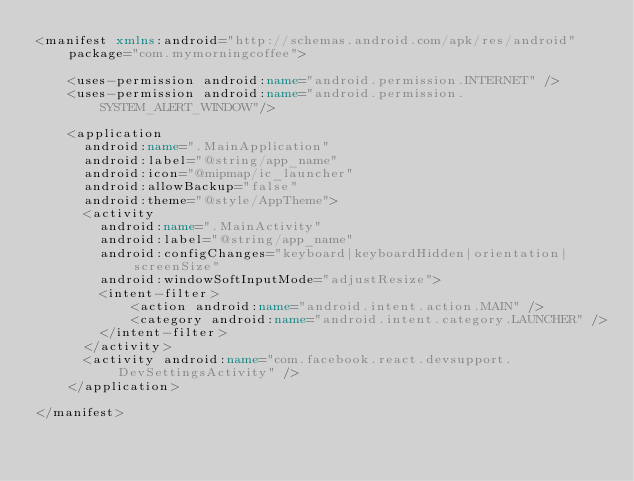Convert code to text. <code><loc_0><loc_0><loc_500><loc_500><_XML_><manifest xmlns:android="http://schemas.android.com/apk/res/android"
    package="com.mymorningcoffee">

    <uses-permission android:name="android.permission.INTERNET" />
    <uses-permission android:name="android.permission.SYSTEM_ALERT_WINDOW"/>

    <application
      android:name=".MainApplication"
      android:label="@string/app_name"
      android:icon="@mipmap/ic_launcher"
      android:allowBackup="false"
      android:theme="@style/AppTheme">
      <activity
        android:name=".MainActivity"
        android:label="@string/app_name"
        android:configChanges="keyboard|keyboardHidden|orientation|screenSize"
        android:windowSoftInputMode="adjustResize">
        <intent-filter>
            <action android:name="android.intent.action.MAIN" />
            <category android:name="android.intent.category.LAUNCHER" />
        </intent-filter>
      </activity>
      <activity android:name="com.facebook.react.devsupport.DevSettingsActivity" />
    </application>

</manifest>
</code> 